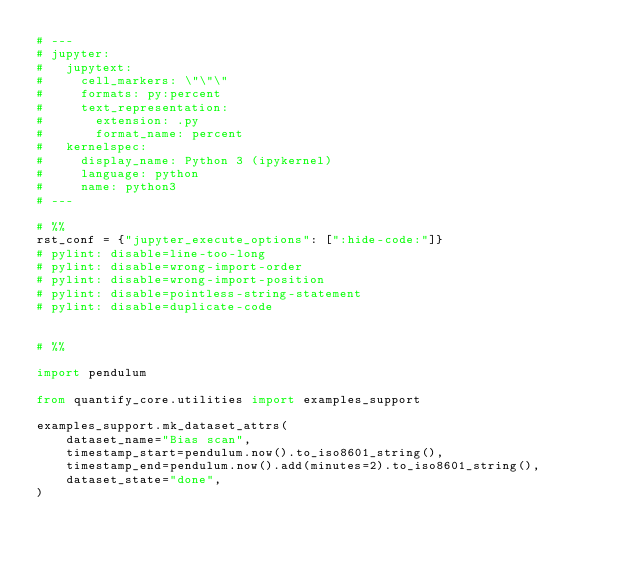Convert code to text. <code><loc_0><loc_0><loc_500><loc_500><_Python_># ---
# jupyter:
#   jupytext:
#     cell_markers: \"\"\"
#     formats: py:percent
#     text_representation:
#       extension: .py
#       format_name: percent
#   kernelspec:
#     display_name: Python 3 (ipykernel)
#     language: python
#     name: python3
# ---

# %%
rst_conf = {"jupyter_execute_options": [":hide-code:"]}
# pylint: disable=line-too-long
# pylint: disable=wrong-import-order
# pylint: disable=wrong-import-position
# pylint: disable=pointless-string-statement
# pylint: disable=duplicate-code


# %%

import pendulum

from quantify_core.utilities import examples_support

examples_support.mk_dataset_attrs(
    dataset_name="Bias scan",
    timestamp_start=pendulum.now().to_iso8601_string(),
    timestamp_end=pendulum.now().add(minutes=2).to_iso8601_string(),
    dataset_state="done",
)
</code> 